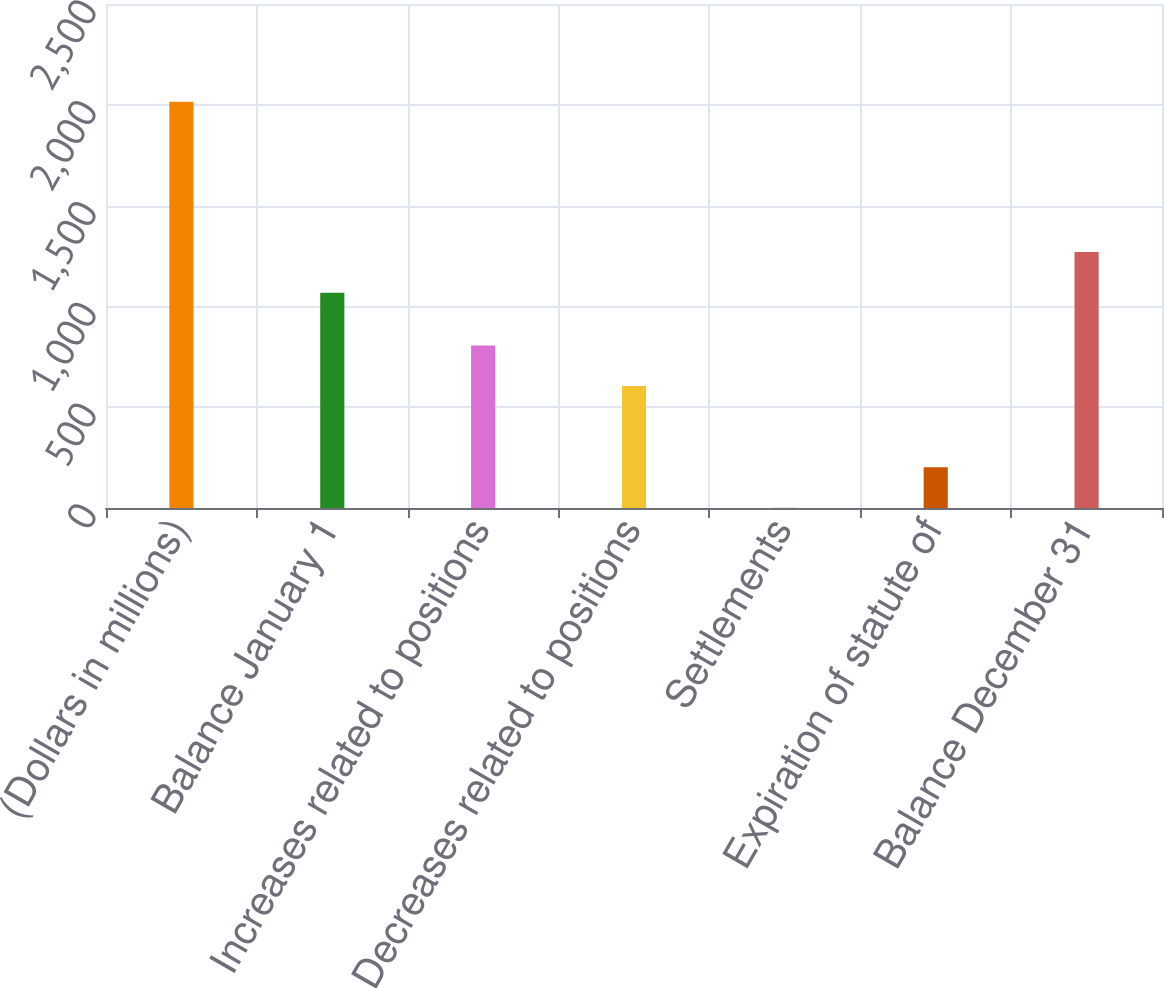Convert chart. <chart><loc_0><loc_0><loc_500><loc_500><bar_chart><fcel>(Dollars in millions)<fcel>Balance January 1<fcel>Increases related to positions<fcel>Decreases related to positions<fcel>Settlements<fcel>Expiration of statute of<fcel>Balance December 31<nl><fcel>2015<fcel>1068<fcel>806.6<fcel>605.2<fcel>1<fcel>202.4<fcel>1269.4<nl></chart> 